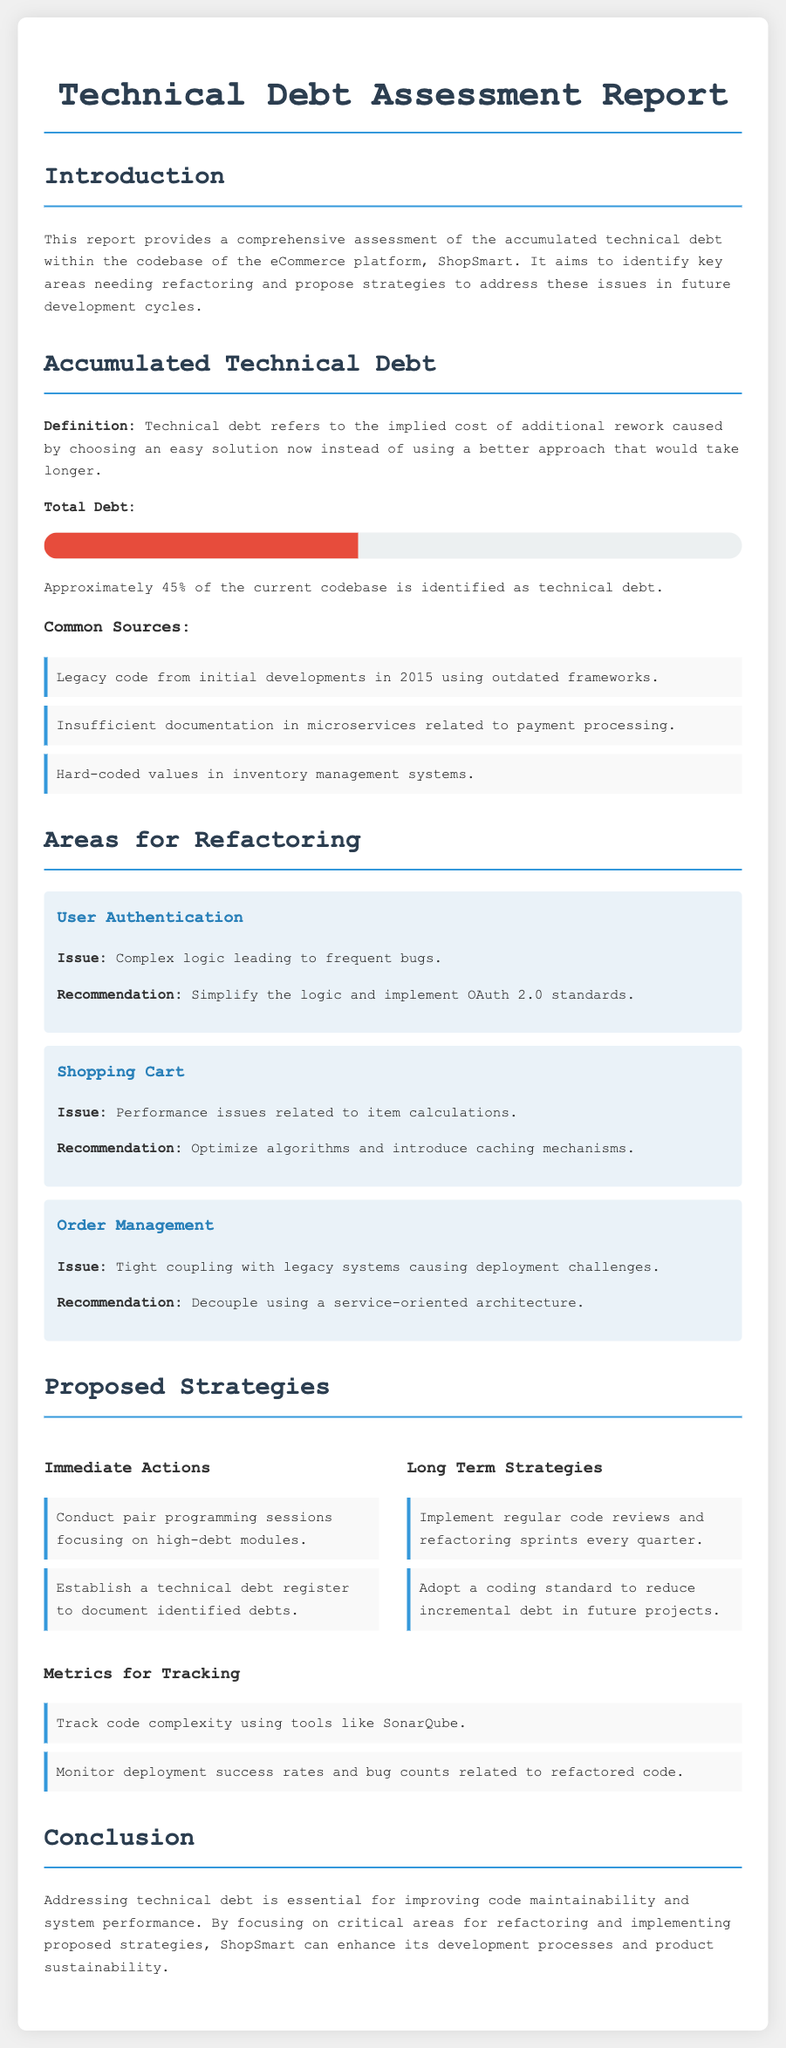What is the title of the report? The title of the report is indicated at the top of the document.
Answer: Technical Debt Assessment Report What percentage of the codebase is identified as technical debt? The document states the percentage of the codebase considered as technical debt.
Answer: 45% What is one common source of technical debt mentioned? The document lists specific sources of technical debt.
Answer: Legacy code from initial developments in 2015 using outdated frameworks What is the recommended action for User Authentication? The recommendation for User Authentication is detailed in the areas for refactoring section.
Answer: Simplify the logic and implement OAuth 2.0 standards What are the immediate actions proposed? Immediate actions are outlined in the proposed strategies section.
Answer: Conduct pair programming sessions focusing on high-debt modules What long-term strategy is suggested? The document provides a long-term strategy relevant to maintaining code quality.
Answer: Implement regular code reviews and refactoring sprints every quarter What tool is suggested for tracking code complexity? The document recommends a specific tool for monitoring code complexity.
Answer: SonarQube What is the focus of the conclusion? The conclusion summarizes the main focus of the report.
Answer: Addressing technical debt is essential for improving code maintainability and system performance 